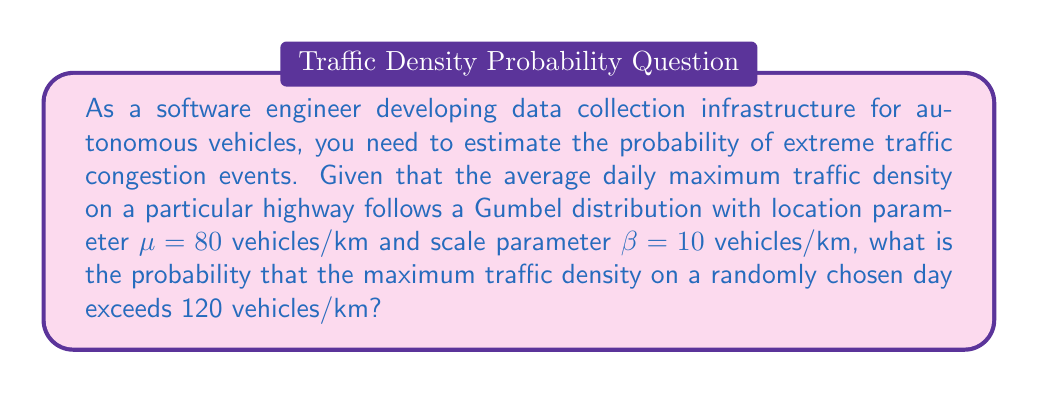Give your solution to this math problem. To solve this problem, we'll use the Gumbel distribution, which is commonly used in extreme value theory for modeling maxima.

Step 1: Recall the cumulative distribution function (CDF) of the Gumbel distribution:
$$F(x; \mu, \beta) = e^{-e^{-(x-\mu)/\beta}}$$

Step 2: We want to find the probability that the maximum traffic density (X) exceeds 120 vehicles/km:
$$P(X > 120) = 1 - P(X \leq 120) = 1 - F(120; 80, 10)$$

Step 3: Substitute the values into the CDF:
$$1 - F(120; 80, 10) = 1 - e^{-e^{-(120-80)/10}}$$

Step 4: Simplify the expression inside the exponential:
$$1 - e^{-e^{-4}}$$

Step 5: Calculate the value:
$$1 - e^{-e^{-4}} \approx 0.0180$$

Step 6: Convert to a percentage:
$$0.0180 \times 100\% = 1.80\%$$
Answer: 1.80% 